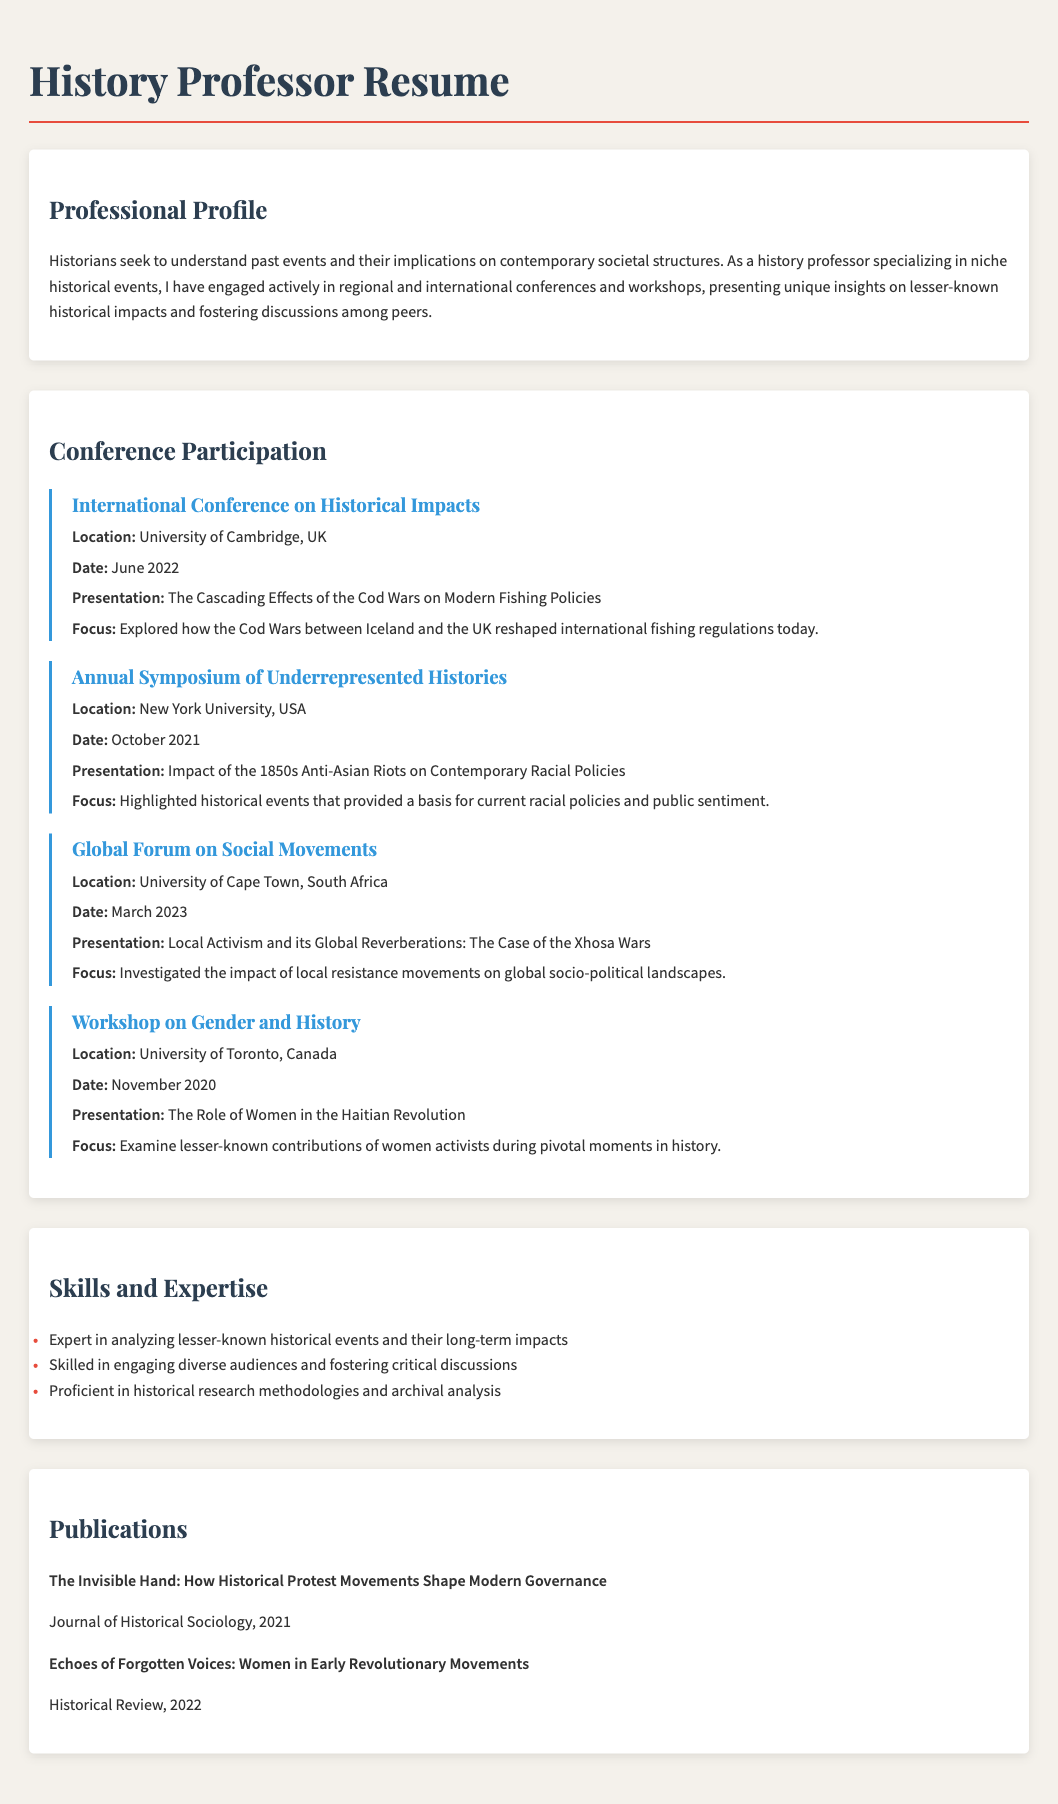What is the title of the resume? The title indicates the document's content and purpose, which is focused on the individual’s professional qualifications in history.
Answer: History Professor Resume What was the location of the International Conference on Historical Impacts? The location provides context for where the conference took place, adding significance to the presentation's relevance.
Answer: University of Cambridge, UK What was the date of the workshop on Gender and History? This date indicates when the workshop occurred, which is important for understanding the timeline of the individual's professional activities.
Answer: November 2020 What was the presentation topic at the Global Forum on Social Movements? The presentation topic highlights the theme of the discussion and the focus of the research conducted by the professor.
Answer: Local Activism and its Global Reverberations: The Case of the Xhosa Wars How many conferences were held in 2022? This shows the level of engagement the professor had in that specific year and reflects on their professional activity.
Answer: 1 What emphasis did the presentation at the Annual Symposium of Underrepresented Histories have? This question explores the relevance of the historical themes being discussed and their contemporary implications.
Answer: Impact of the 1850s Anti-Asian Riots on Contemporary Racial Policies What is one of the skills listed in the resume? This question shows the expertise areas of the individual, providing insight into their professional capabilities.
Answer: Expert in analyzing lesser-known historical events and their long-term impacts In which journal was the publication "Echoes of Forgotten Voices: Women in Early Revolutionary Movements" published? Knowing the journal adds credibility to the publication and showcases the individual's academic contributions.
Answer: Historical Review 